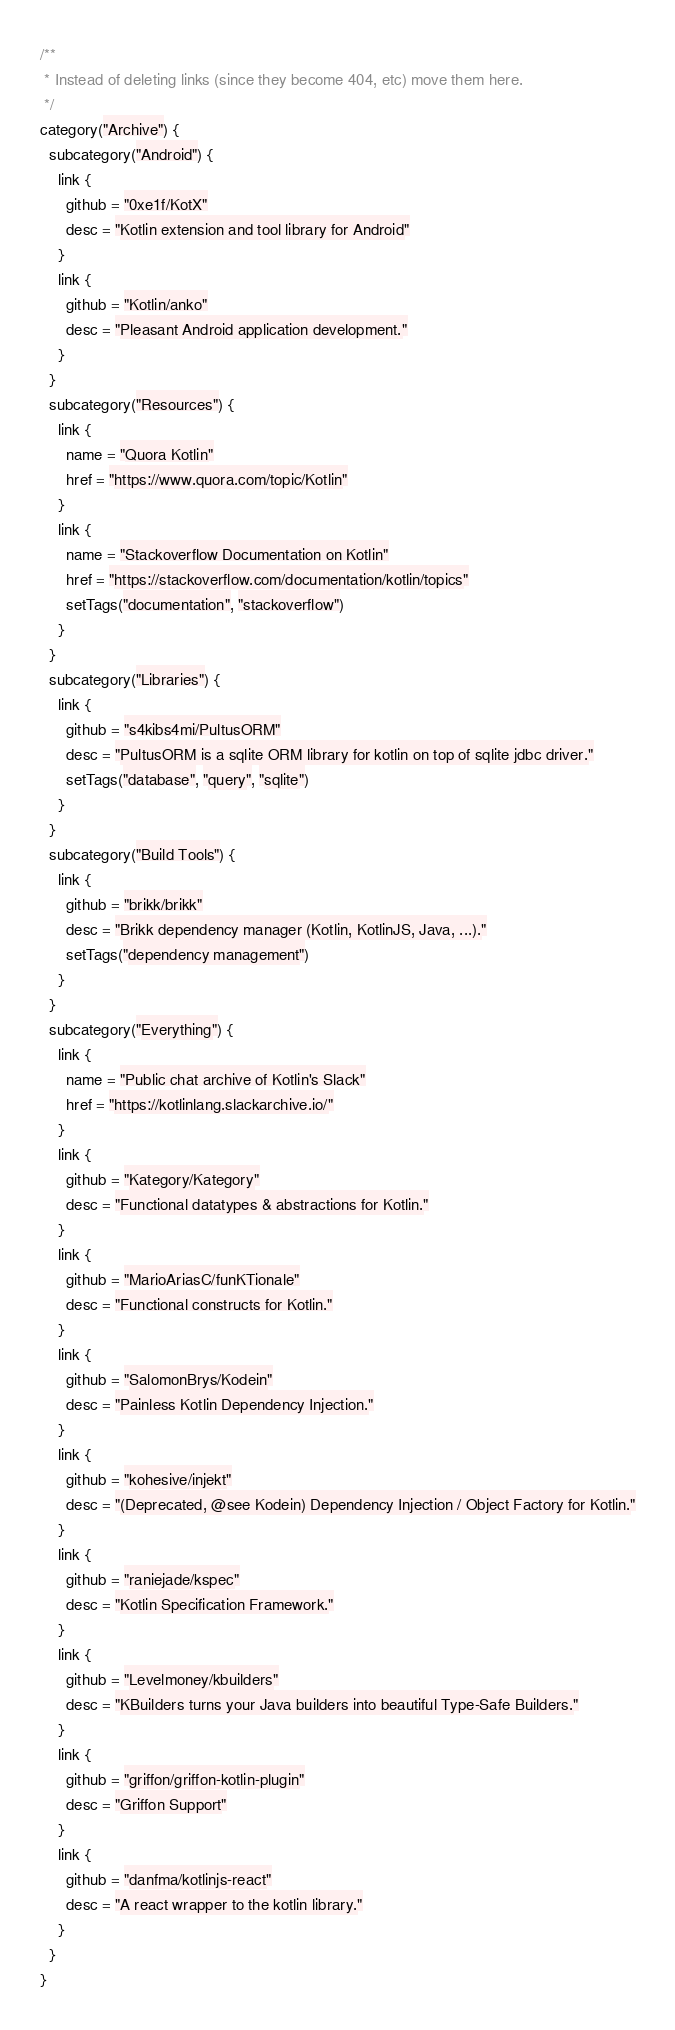Convert code to text. <code><loc_0><loc_0><loc_500><loc_500><_Kotlin_>/**
 * Instead of deleting links (since they become 404, etc) move them here.
 */
category("Archive") {
  subcategory("Android") {
    link {
      github = "0xe1f/KotX"
      desc = "Kotlin extension and tool library for Android"
    }
    link {
      github = "Kotlin/anko"
      desc = "Pleasant Android application development."
    }
  }
  subcategory("Resources") {
    link {
      name = "Quora Kotlin"
      href = "https://www.quora.com/topic/Kotlin"
    }
    link {
      name = "Stackoverflow Documentation on Kotlin"
      href = "https://stackoverflow.com/documentation/kotlin/topics"
      setTags("documentation", "stackoverflow")
    }
  }
  subcategory("Libraries") {
    link {
      github = "s4kibs4mi/PultusORM"
      desc = "PultusORM is a sqlite ORM library for kotlin on top of sqlite jdbc driver."
      setTags("database", "query", "sqlite")
    }
  }
  subcategory("Build Tools") {
    link {
      github = "brikk/brikk"
      desc = "Brikk dependency manager (Kotlin, KotlinJS, Java, ...)."
      setTags("dependency management")
    }
  }
  subcategory("Everything") {
    link {
      name = "Public chat archive of Kotlin's Slack"
      href = "https://kotlinlang.slackarchive.io/"
    }
    link {
      github = "Kategory/Kategory"
      desc = "Functional datatypes & abstractions for Kotlin."
    }
    link {
      github = "MarioAriasC/funKTionale"
      desc = "Functional constructs for Kotlin."
    }
    link {
      github = "SalomonBrys/Kodein"
      desc = "Painless Kotlin Dependency Injection."
    }
    link {
      github = "kohesive/injekt"
      desc = "(Deprecated, @see Kodein) Dependency Injection / Object Factory for Kotlin."
    }
    link {
      github = "raniejade/kspec"
      desc = "Kotlin Specification Framework."
    }
    link {
      github = "Levelmoney/kbuilders"
      desc = "KBuilders turns your Java builders into beautiful Type-Safe Builders."
    }
    link {
      github = "griffon/griffon-kotlin-plugin"
      desc = "Griffon Support"
    }
    link {
      github = "danfma/kotlinjs-react"
      desc = "A react wrapper to the kotlin library."
    }
  }
}
</code> 